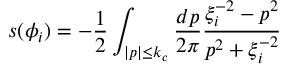<formula> <loc_0><loc_0><loc_500><loc_500>s ( \phi _ { i } ) = - \frac { 1 } { 2 } \int _ { | p | \leq k _ { c } } \frac { d p } { 2 \pi } \frac { \xi _ { i } ^ { - 2 } - p ^ { 2 } } { p ^ { 2 } + \xi _ { i } ^ { - 2 } }</formula> 